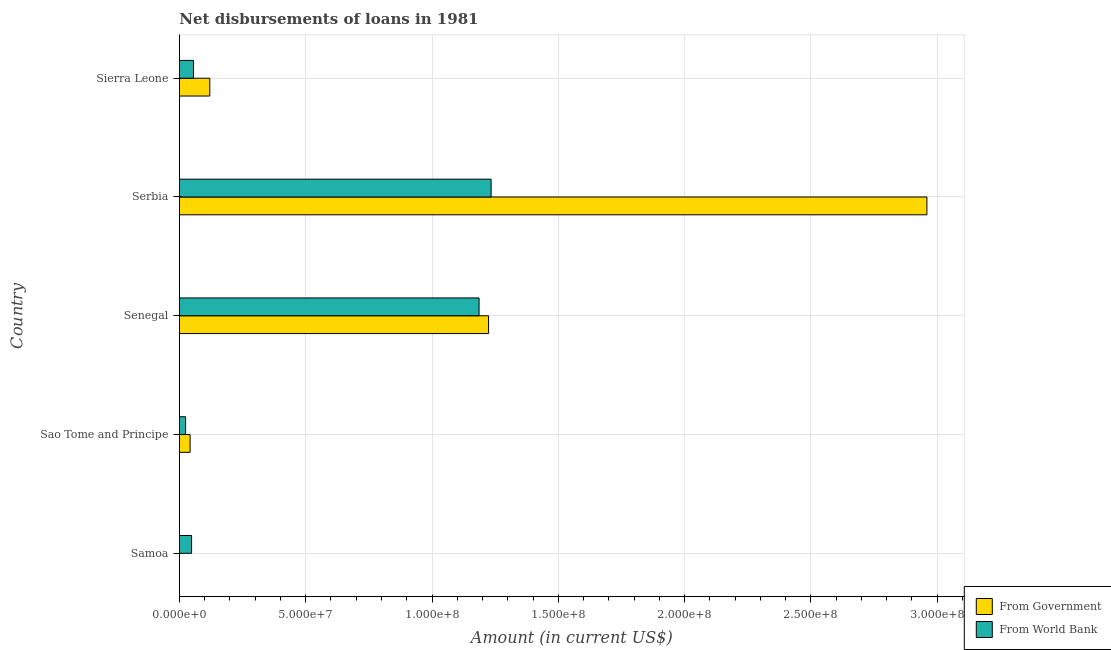How many bars are there on the 2nd tick from the bottom?
Give a very brief answer. 2. What is the label of the 4th group of bars from the top?
Give a very brief answer. Sao Tome and Principe. In how many cases, is the number of bars for a given country not equal to the number of legend labels?
Your answer should be very brief. 0. What is the net disbursements of loan from government in Sierra Leone?
Offer a terse response. 1.20e+07. Across all countries, what is the maximum net disbursements of loan from world bank?
Your response must be concise. 1.23e+08. Across all countries, what is the minimum net disbursements of loan from world bank?
Your answer should be compact. 2.45e+06. In which country was the net disbursements of loan from world bank maximum?
Keep it short and to the point. Serbia. In which country was the net disbursements of loan from world bank minimum?
Provide a succinct answer. Sao Tome and Principe. What is the total net disbursements of loan from government in the graph?
Provide a succinct answer. 4.35e+08. What is the difference between the net disbursements of loan from world bank in Sao Tome and Principe and that in Sierra Leone?
Give a very brief answer. -3.13e+06. What is the difference between the net disbursements of loan from government in Serbia and the net disbursements of loan from world bank in Senegal?
Give a very brief answer. 1.77e+08. What is the average net disbursements of loan from world bank per country?
Your answer should be very brief. 5.10e+07. What is the difference between the net disbursements of loan from government and net disbursements of loan from world bank in Samoa?
Your answer should be compact. -4.80e+06. In how many countries, is the net disbursements of loan from world bank greater than 150000000 US$?
Offer a terse response. 0. What is the ratio of the net disbursements of loan from government in Sao Tome and Principe to that in Sierra Leone?
Your response must be concise. 0.35. What is the difference between the highest and the second highest net disbursements of loan from world bank?
Give a very brief answer. 4.77e+06. What is the difference between the highest and the lowest net disbursements of loan from government?
Your response must be concise. 2.96e+08. What does the 2nd bar from the top in Sierra Leone represents?
Ensure brevity in your answer.  From Government. What does the 2nd bar from the bottom in Sao Tome and Principe represents?
Offer a very short reply. From World Bank. Are all the bars in the graph horizontal?
Provide a short and direct response. Yes. Are the values on the major ticks of X-axis written in scientific E-notation?
Your answer should be compact. Yes. Does the graph contain grids?
Provide a short and direct response. Yes. Where does the legend appear in the graph?
Keep it short and to the point. Bottom right. How many legend labels are there?
Provide a succinct answer. 2. What is the title of the graph?
Keep it short and to the point. Net disbursements of loans in 1981. Does "All education staff compensation" appear as one of the legend labels in the graph?
Offer a very short reply. No. What is the label or title of the Y-axis?
Your answer should be very brief. Country. What is the Amount (in current US$) of From Government in Samoa?
Provide a short and direct response. 10000. What is the Amount (in current US$) of From World Bank in Samoa?
Offer a very short reply. 4.81e+06. What is the Amount (in current US$) in From Government in Sao Tome and Principe?
Make the answer very short. 4.23e+06. What is the Amount (in current US$) in From World Bank in Sao Tome and Principe?
Provide a short and direct response. 2.45e+06. What is the Amount (in current US$) in From Government in Senegal?
Offer a very short reply. 1.22e+08. What is the Amount (in current US$) in From World Bank in Senegal?
Offer a very short reply. 1.19e+08. What is the Amount (in current US$) of From Government in Serbia?
Keep it short and to the point. 2.96e+08. What is the Amount (in current US$) in From World Bank in Serbia?
Your response must be concise. 1.23e+08. What is the Amount (in current US$) in From Government in Sierra Leone?
Make the answer very short. 1.20e+07. What is the Amount (in current US$) in From World Bank in Sierra Leone?
Give a very brief answer. 5.58e+06. Across all countries, what is the maximum Amount (in current US$) of From Government?
Keep it short and to the point. 2.96e+08. Across all countries, what is the maximum Amount (in current US$) in From World Bank?
Offer a very short reply. 1.23e+08. Across all countries, what is the minimum Amount (in current US$) in From World Bank?
Your response must be concise. 2.45e+06. What is the total Amount (in current US$) of From Government in the graph?
Give a very brief answer. 4.35e+08. What is the total Amount (in current US$) in From World Bank in the graph?
Offer a very short reply. 2.55e+08. What is the difference between the Amount (in current US$) in From Government in Samoa and that in Sao Tome and Principe?
Keep it short and to the point. -4.22e+06. What is the difference between the Amount (in current US$) in From World Bank in Samoa and that in Sao Tome and Principe?
Your answer should be very brief. 2.36e+06. What is the difference between the Amount (in current US$) in From Government in Samoa and that in Senegal?
Ensure brevity in your answer.  -1.22e+08. What is the difference between the Amount (in current US$) of From World Bank in Samoa and that in Senegal?
Your response must be concise. -1.14e+08. What is the difference between the Amount (in current US$) of From Government in Samoa and that in Serbia?
Make the answer very short. -2.96e+08. What is the difference between the Amount (in current US$) of From World Bank in Samoa and that in Serbia?
Give a very brief answer. -1.19e+08. What is the difference between the Amount (in current US$) of From Government in Samoa and that in Sierra Leone?
Your answer should be compact. -1.20e+07. What is the difference between the Amount (in current US$) of From World Bank in Samoa and that in Sierra Leone?
Your answer should be very brief. -7.62e+05. What is the difference between the Amount (in current US$) of From Government in Sao Tome and Principe and that in Senegal?
Offer a very short reply. -1.18e+08. What is the difference between the Amount (in current US$) of From World Bank in Sao Tome and Principe and that in Senegal?
Your answer should be compact. -1.16e+08. What is the difference between the Amount (in current US$) of From Government in Sao Tome and Principe and that in Serbia?
Your response must be concise. -2.92e+08. What is the difference between the Amount (in current US$) of From World Bank in Sao Tome and Principe and that in Serbia?
Ensure brevity in your answer.  -1.21e+08. What is the difference between the Amount (in current US$) in From Government in Sao Tome and Principe and that in Sierra Leone?
Offer a terse response. -7.81e+06. What is the difference between the Amount (in current US$) of From World Bank in Sao Tome and Principe and that in Sierra Leone?
Give a very brief answer. -3.13e+06. What is the difference between the Amount (in current US$) of From Government in Senegal and that in Serbia?
Your response must be concise. -1.74e+08. What is the difference between the Amount (in current US$) in From World Bank in Senegal and that in Serbia?
Give a very brief answer. -4.77e+06. What is the difference between the Amount (in current US$) in From Government in Senegal and that in Sierra Leone?
Your answer should be very brief. 1.10e+08. What is the difference between the Amount (in current US$) of From World Bank in Senegal and that in Sierra Leone?
Offer a terse response. 1.13e+08. What is the difference between the Amount (in current US$) of From Government in Serbia and that in Sierra Leone?
Offer a very short reply. 2.84e+08. What is the difference between the Amount (in current US$) in From World Bank in Serbia and that in Sierra Leone?
Provide a succinct answer. 1.18e+08. What is the difference between the Amount (in current US$) in From Government in Samoa and the Amount (in current US$) in From World Bank in Sao Tome and Principe?
Offer a terse response. -2.44e+06. What is the difference between the Amount (in current US$) in From Government in Samoa and the Amount (in current US$) in From World Bank in Senegal?
Make the answer very short. -1.19e+08. What is the difference between the Amount (in current US$) of From Government in Samoa and the Amount (in current US$) of From World Bank in Serbia?
Offer a very short reply. -1.23e+08. What is the difference between the Amount (in current US$) in From Government in Samoa and the Amount (in current US$) in From World Bank in Sierra Leone?
Offer a terse response. -5.57e+06. What is the difference between the Amount (in current US$) in From Government in Sao Tome and Principe and the Amount (in current US$) in From World Bank in Senegal?
Ensure brevity in your answer.  -1.14e+08. What is the difference between the Amount (in current US$) in From Government in Sao Tome and Principe and the Amount (in current US$) in From World Bank in Serbia?
Make the answer very short. -1.19e+08. What is the difference between the Amount (in current US$) of From Government in Sao Tome and Principe and the Amount (in current US$) of From World Bank in Sierra Leone?
Ensure brevity in your answer.  -1.35e+06. What is the difference between the Amount (in current US$) in From Government in Senegal and the Amount (in current US$) in From World Bank in Serbia?
Make the answer very short. -1.01e+06. What is the difference between the Amount (in current US$) of From Government in Senegal and the Amount (in current US$) of From World Bank in Sierra Leone?
Ensure brevity in your answer.  1.17e+08. What is the difference between the Amount (in current US$) of From Government in Serbia and the Amount (in current US$) of From World Bank in Sierra Leone?
Your answer should be compact. 2.90e+08. What is the average Amount (in current US$) of From Government per country?
Offer a terse response. 8.69e+07. What is the average Amount (in current US$) of From World Bank per country?
Provide a succinct answer. 5.10e+07. What is the difference between the Amount (in current US$) in From Government and Amount (in current US$) in From World Bank in Samoa?
Provide a succinct answer. -4.80e+06. What is the difference between the Amount (in current US$) of From Government and Amount (in current US$) of From World Bank in Sao Tome and Principe?
Your answer should be compact. 1.78e+06. What is the difference between the Amount (in current US$) in From Government and Amount (in current US$) in From World Bank in Senegal?
Keep it short and to the point. 3.77e+06. What is the difference between the Amount (in current US$) in From Government and Amount (in current US$) in From World Bank in Serbia?
Provide a short and direct response. 1.73e+08. What is the difference between the Amount (in current US$) in From Government and Amount (in current US$) in From World Bank in Sierra Leone?
Ensure brevity in your answer.  6.46e+06. What is the ratio of the Amount (in current US$) of From Government in Samoa to that in Sao Tome and Principe?
Provide a short and direct response. 0. What is the ratio of the Amount (in current US$) of From World Bank in Samoa to that in Sao Tome and Principe?
Your response must be concise. 1.97. What is the ratio of the Amount (in current US$) of From Government in Samoa to that in Senegal?
Provide a short and direct response. 0. What is the ratio of the Amount (in current US$) in From World Bank in Samoa to that in Senegal?
Your answer should be compact. 0.04. What is the ratio of the Amount (in current US$) in From Government in Samoa to that in Serbia?
Offer a very short reply. 0. What is the ratio of the Amount (in current US$) in From World Bank in Samoa to that in Serbia?
Ensure brevity in your answer.  0.04. What is the ratio of the Amount (in current US$) in From Government in Samoa to that in Sierra Leone?
Your answer should be compact. 0. What is the ratio of the Amount (in current US$) of From World Bank in Samoa to that in Sierra Leone?
Offer a very short reply. 0.86. What is the ratio of the Amount (in current US$) in From Government in Sao Tome and Principe to that in Senegal?
Give a very brief answer. 0.03. What is the ratio of the Amount (in current US$) of From World Bank in Sao Tome and Principe to that in Senegal?
Your response must be concise. 0.02. What is the ratio of the Amount (in current US$) in From Government in Sao Tome and Principe to that in Serbia?
Your answer should be compact. 0.01. What is the ratio of the Amount (in current US$) in From World Bank in Sao Tome and Principe to that in Serbia?
Provide a succinct answer. 0.02. What is the ratio of the Amount (in current US$) in From Government in Sao Tome and Principe to that in Sierra Leone?
Offer a terse response. 0.35. What is the ratio of the Amount (in current US$) in From World Bank in Sao Tome and Principe to that in Sierra Leone?
Your answer should be compact. 0.44. What is the ratio of the Amount (in current US$) in From Government in Senegal to that in Serbia?
Ensure brevity in your answer.  0.41. What is the ratio of the Amount (in current US$) in From World Bank in Senegal to that in Serbia?
Provide a short and direct response. 0.96. What is the ratio of the Amount (in current US$) in From Government in Senegal to that in Sierra Leone?
Give a very brief answer. 10.17. What is the ratio of the Amount (in current US$) of From World Bank in Senegal to that in Sierra Leone?
Your answer should be very brief. 21.28. What is the ratio of the Amount (in current US$) of From Government in Serbia to that in Sierra Leone?
Offer a very short reply. 24.58. What is the ratio of the Amount (in current US$) in From World Bank in Serbia to that in Sierra Leone?
Provide a short and direct response. 22.13. What is the difference between the highest and the second highest Amount (in current US$) of From Government?
Give a very brief answer. 1.74e+08. What is the difference between the highest and the second highest Amount (in current US$) of From World Bank?
Keep it short and to the point. 4.77e+06. What is the difference between the highest and the lowest Amount (in current US$) of From Government?
Offer a very short reply. 2.96e+08. What is the difference between the highest and the lowest Amount (in current US$) in From World Bank?
Provide a succinct answer. 1.21e+08. 